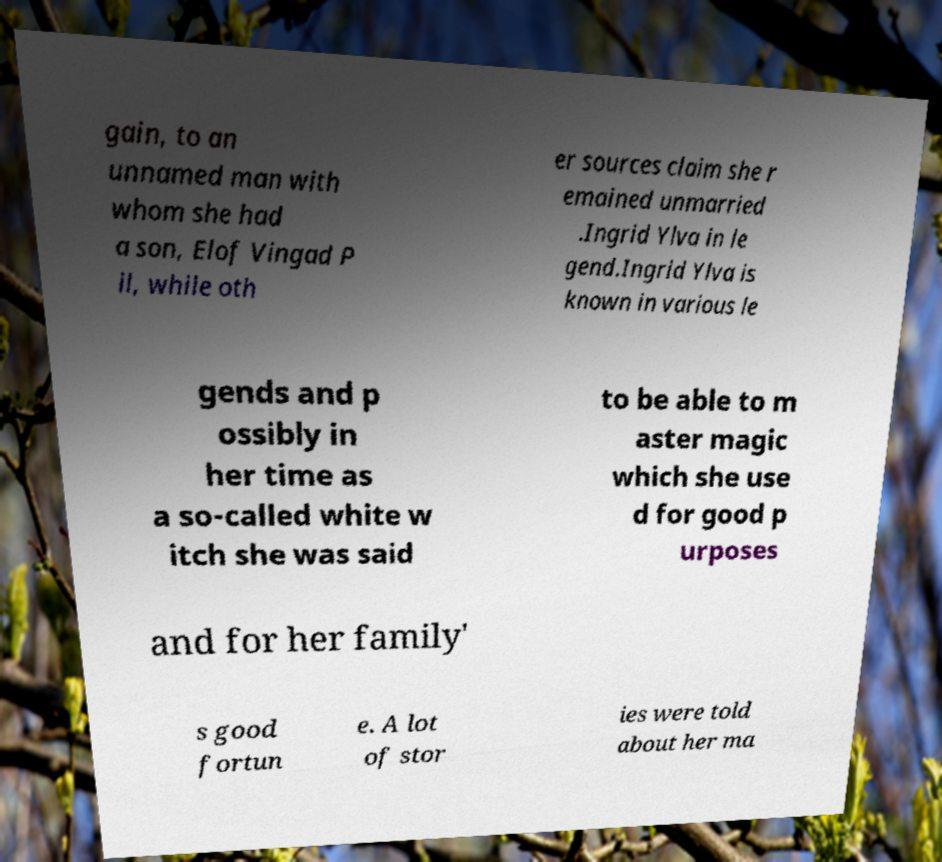What messages or text are displayed in this image? I need them in a readable, typed format. gain, to an unnamed man with whom she had a son, Elof Vingad P il, while oth er sources claim she r emained unmarried .Ingrid Ylva in le gend.Ingrid Ylva is known in various le gends and p ossibly in her time as a so-called white w itch she was said to be able to m aster magic which she use d for good p urposes and for her family' s good fortun e. A lot of stor ies were told about her ma 